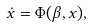Convert formula to latex. <formula><loc_0><loc_0><loc_500><loc_500>\dot { x } = \Phi ( \beta , x ) ,</formula> 